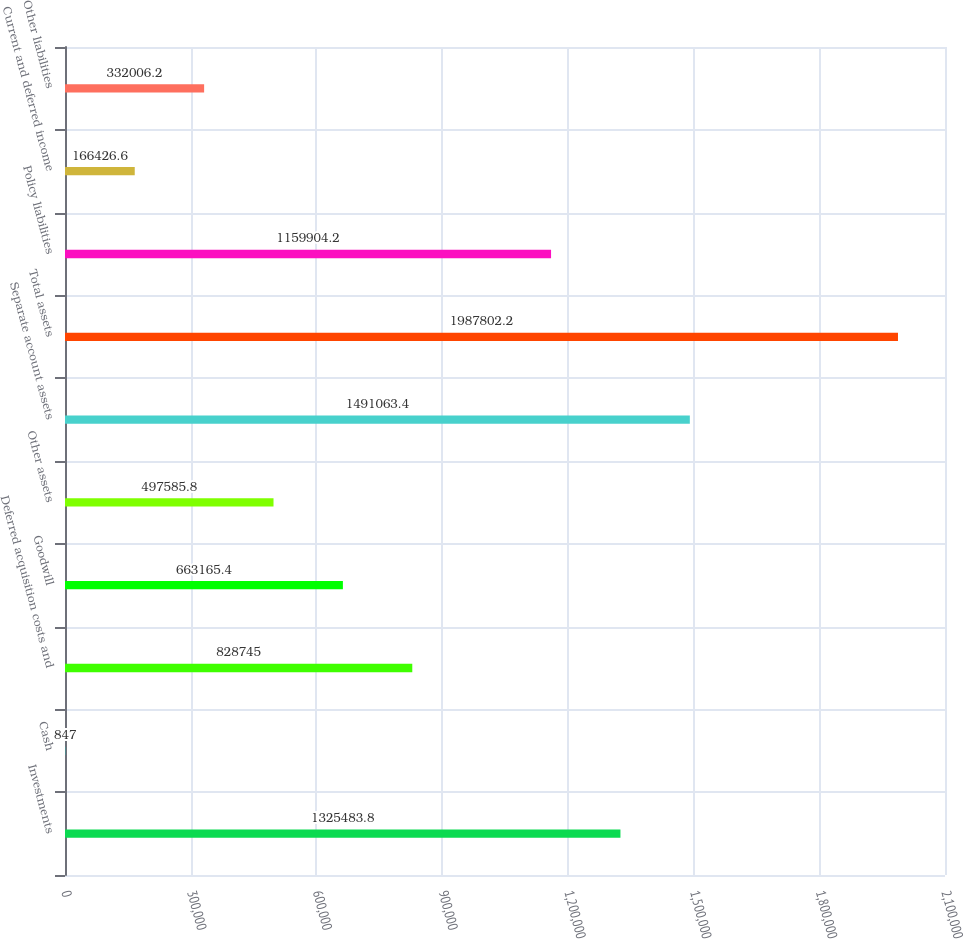Convert chart. <chart><loc_0><loc_0><loc_500><loc_500><bar_chart><fcel>Investments<fcel>Cash<fcel>Deferred acquisition costs and<fcel>Goodwill<fcel>Other assets<fcel>Separate account assets<fcel>Total assets<fcel>Policy liabilities<fcel>Current and deferred income<fcel>Other liabilities<nl><fcel>1.32548e+06<fcel>847<fcel>828745<fcel>663165<fcel>497586<fcel>1.49106e+06<fcel>1.9878e+06<fcel>1.1599e+06<fcel>166427<fcel>332006<nl></chart> 